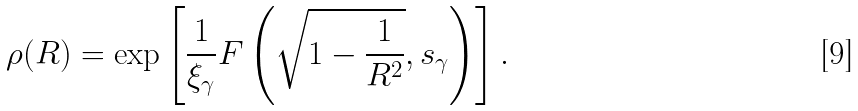Convert formula to latex. <formula><loc_0><loc_0><loc_500><loc_500>\rho ( R ) = \exp \left [ \frac { 1 } { \xi _ { \gamma } } F \left ( \sqrt { 1 - \frac { 1 } { R ^ { 2 } } } , s _ { \gamma } \right ) \right ] .</formula> 